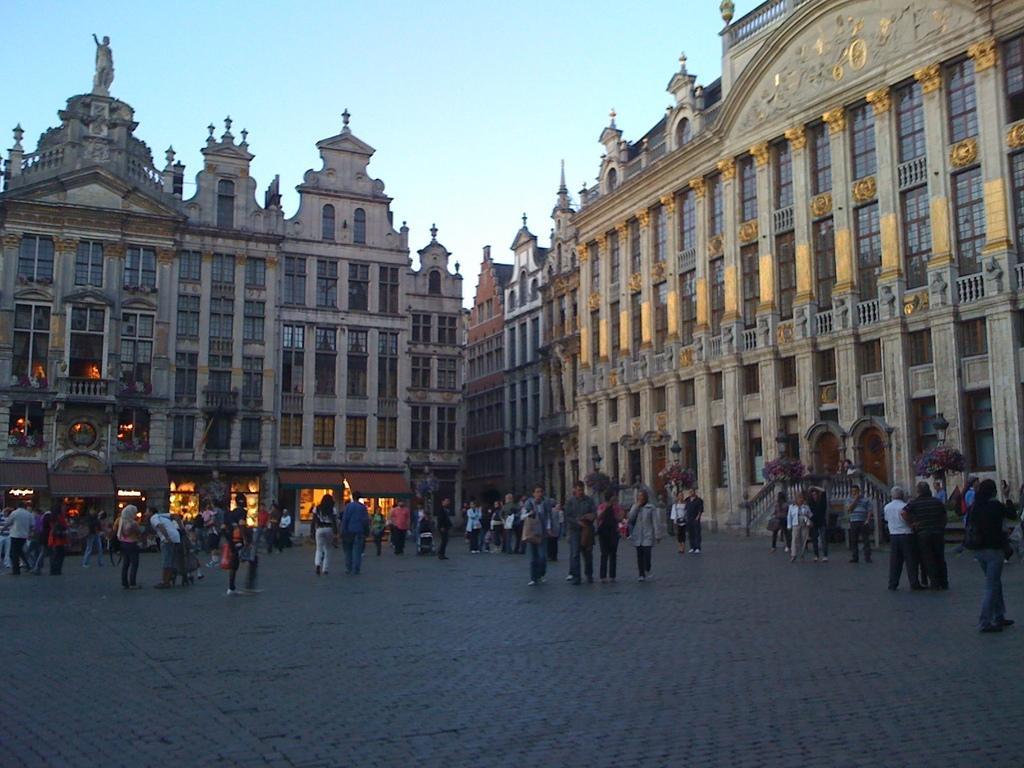Could you give a brief overview of what you see in this image? In this picture there are few persons standing and there are buildings in the background. 